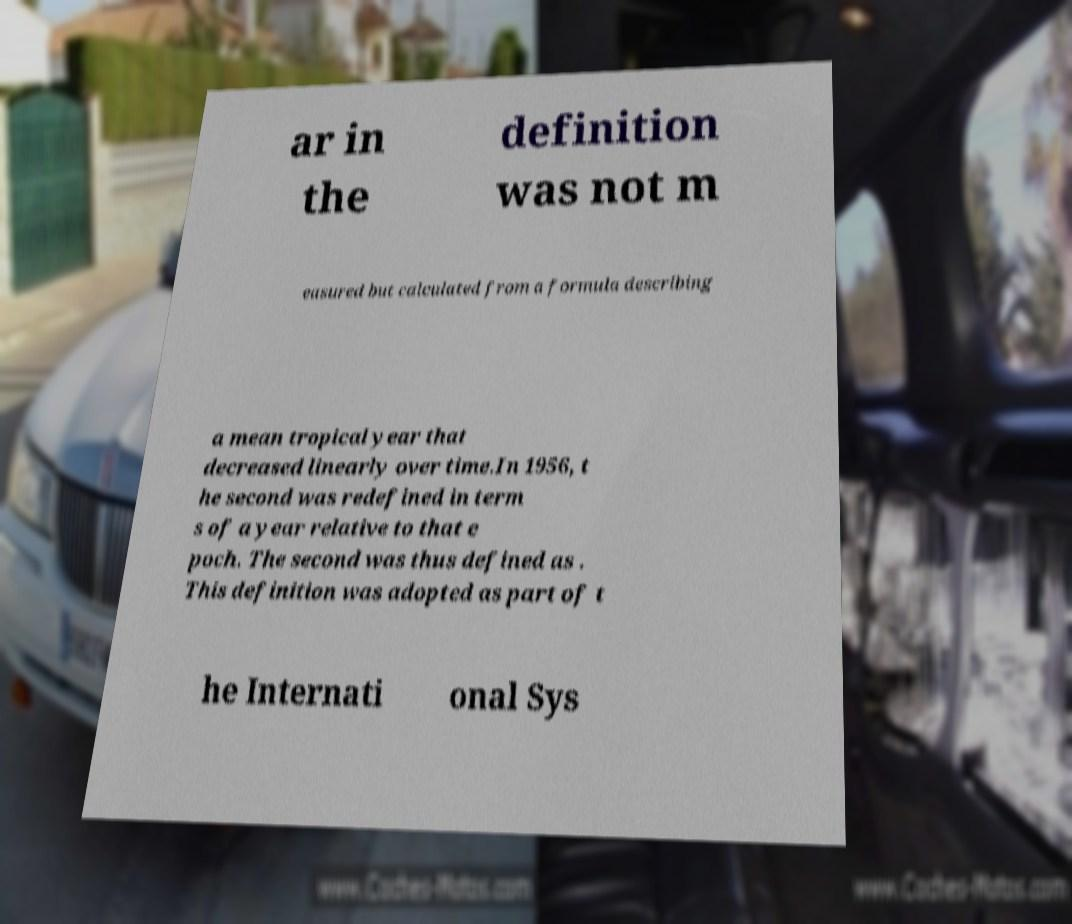Please read and relay the text visible in this image. What does it say? ar in the definition was not m easured but calculated from a formula describing a mean tropical year that decreased linearly over time.In 1956, t he second was redefined in term s of a year relative to that e poch. The second was thus defined as . This definition was adopted as part of t he Internati onal Sys 